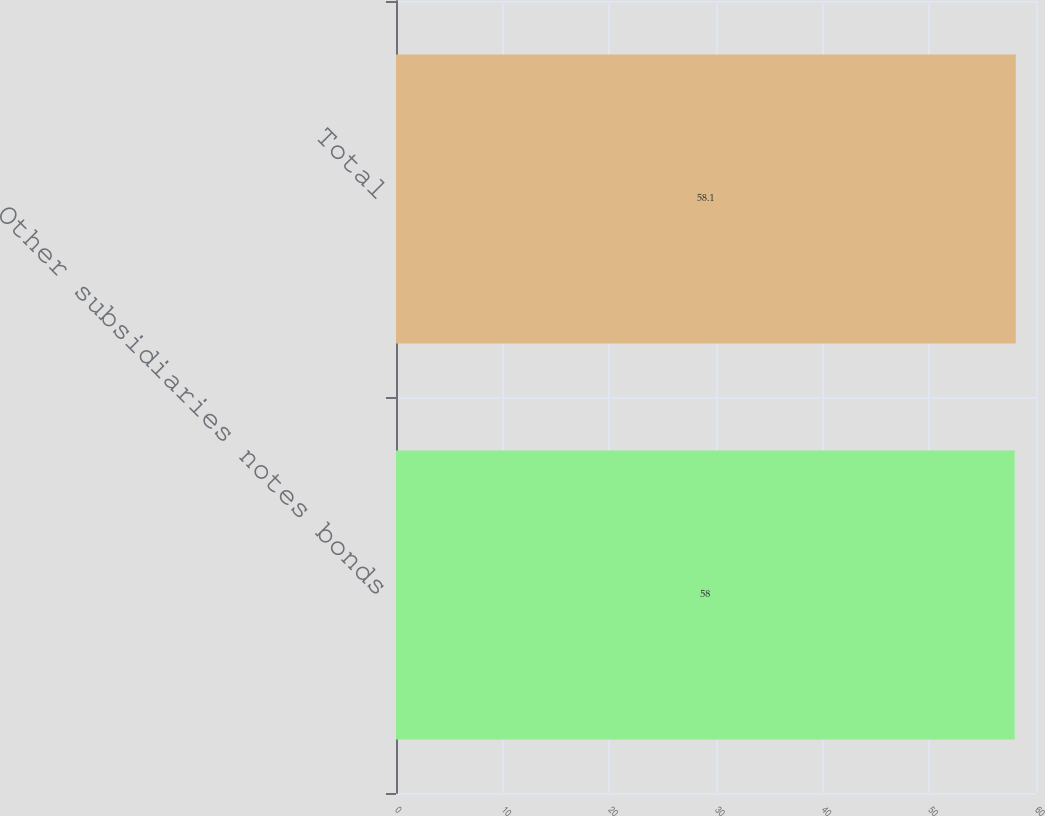Convert chart. <chart><loc_0><loc_0><loc_500><loc_500><bar_chart><fcel>Other subsidiaries notes bonds<fcel>Total<nl><fcel>58<fcel>58.1<nl></chart> 